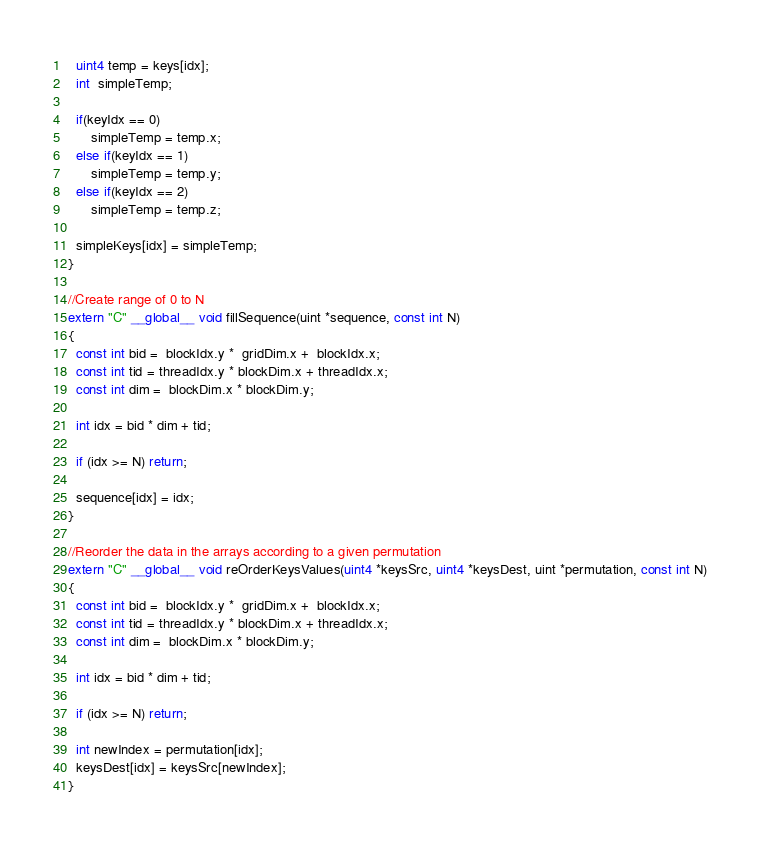<code> <loc_0><loc_0><loc_500><loc_500><_Cuda_>  uint4 temp = keys[idx];
  int  simpleTemp;

  if(keyIdx == 0)
      simpleTemp = temp.x;
  else if(keyIdx == 1)
      simpleTemp = temp.y;
  else if(keyIdx == 2)
      simpleTemp = temp.z;

  simpleKeys[idx] = simpleTemp;
}

//Create range of 0 to N
extern "C" __global__ void fillSequence(uint *sequence, const int N)
{
  const int bid =  blockIdx.y *  gridDim.x +  blockIdx.x;
  const int tid = threadIdx.y * blockDim.x + threadIdx.x;
  const int dim =  blockDim.x * blockDim.y;

  int idx = bid * dim + tid;

  if (idx >= N) return;

  sequence[idx] = idx;
}

//Reorder the data in the arrays according to a given permutation
extern "C" __global__ void reOrderKeysValues(uint4 *keysSrc, uint4 *keysDest, uint *permutation, const int N)
{
  const int bid =  blockIdx.y *  gridDim.x +  blockIdx.x;
  const int tid = threadIdx.y * blockDim.x + threadIdx.x;
  const int dim =  blockDim.x * blockDim.y;

  int idx = bid * dim + tid;

  if (idx >= N) return;

  int newIndex = permutation[idx];
  keysDest[idx] = keysSrc[newIndex];
}
</code> 